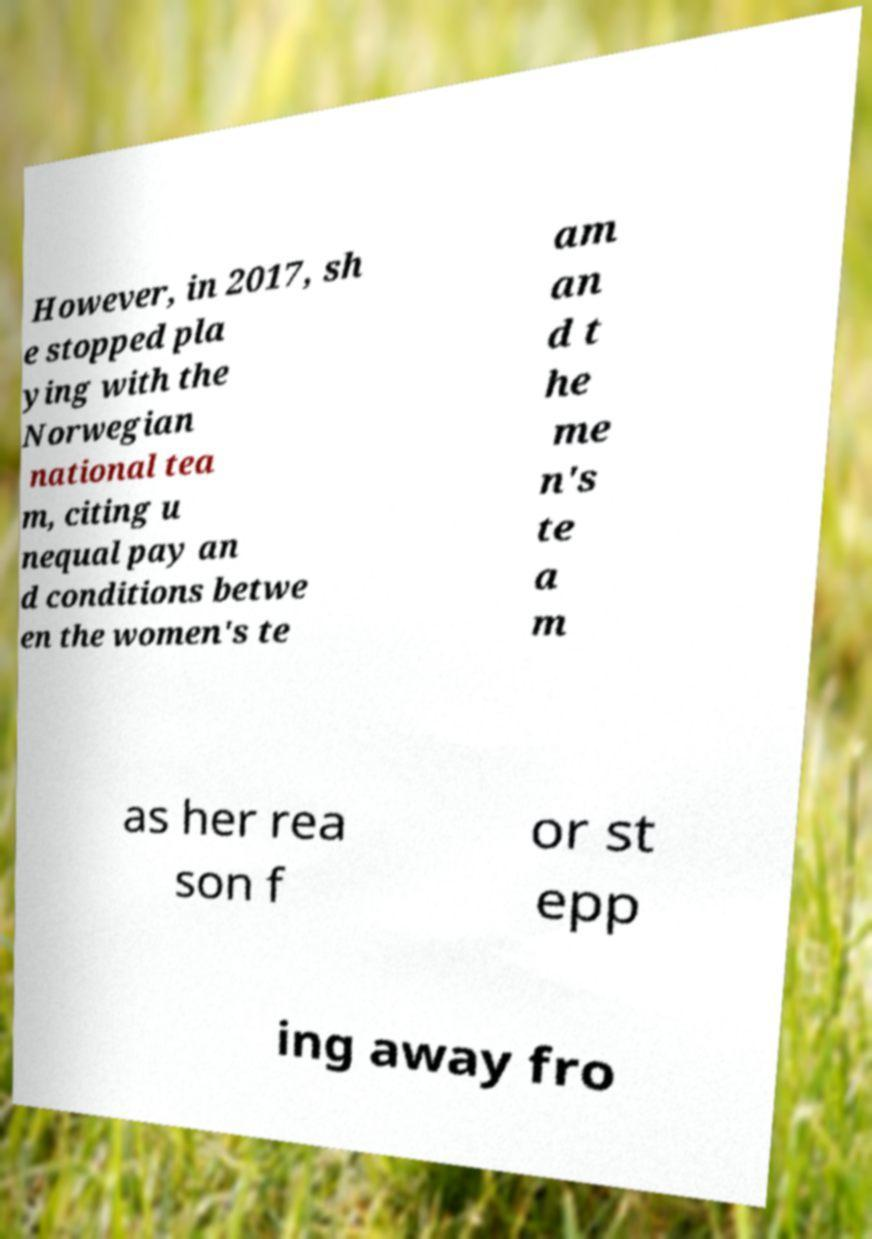Please read and relay the text visible in this image. What does it say? However, in 2017, sh e stopped pla ying with the Norwegian national tea m, citing u nequal pay an d conditions betwe en the women's te am an d t he me n's te a m as her rea son f or st epp ing away fro 